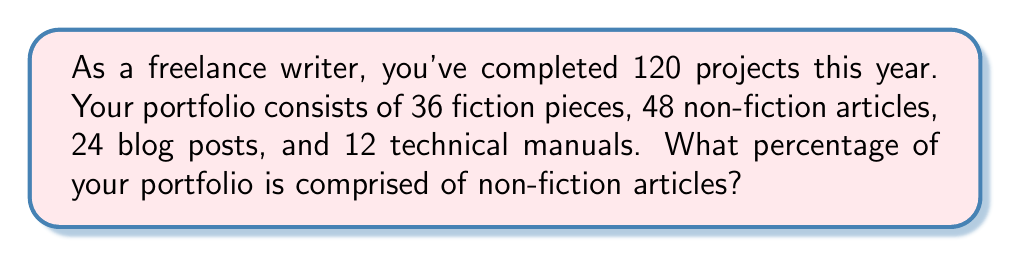Solve this math problem. To solve this problem, we need to follow these steps:

1. Identify the total number of projects: 120

2. Identify the number of non-fiction articles: 48

3. Calculate the percentage using the formula:
   $$ \text{Percentage} = \frac{\text{Part}}{\text{Whole}} \times 100 $$

   Where "Part" is the number of non-fiction articles, and "Whole" is the total number of projects.

4. Plug in the values:
   $$ \text{Percentage} = \frac{48}{120} \times 100 $$

5. Simplify the fraction:
   $$ \text{Percentage} = \frac{2}{5} \times 100 $$

6. Perform the multiplication:
   $$ \text{Percentage} = 0.4 \times 100 = 40 $$

Therefore, non-fiction articles make up 40% of your portfolio.
Answer: 40% 